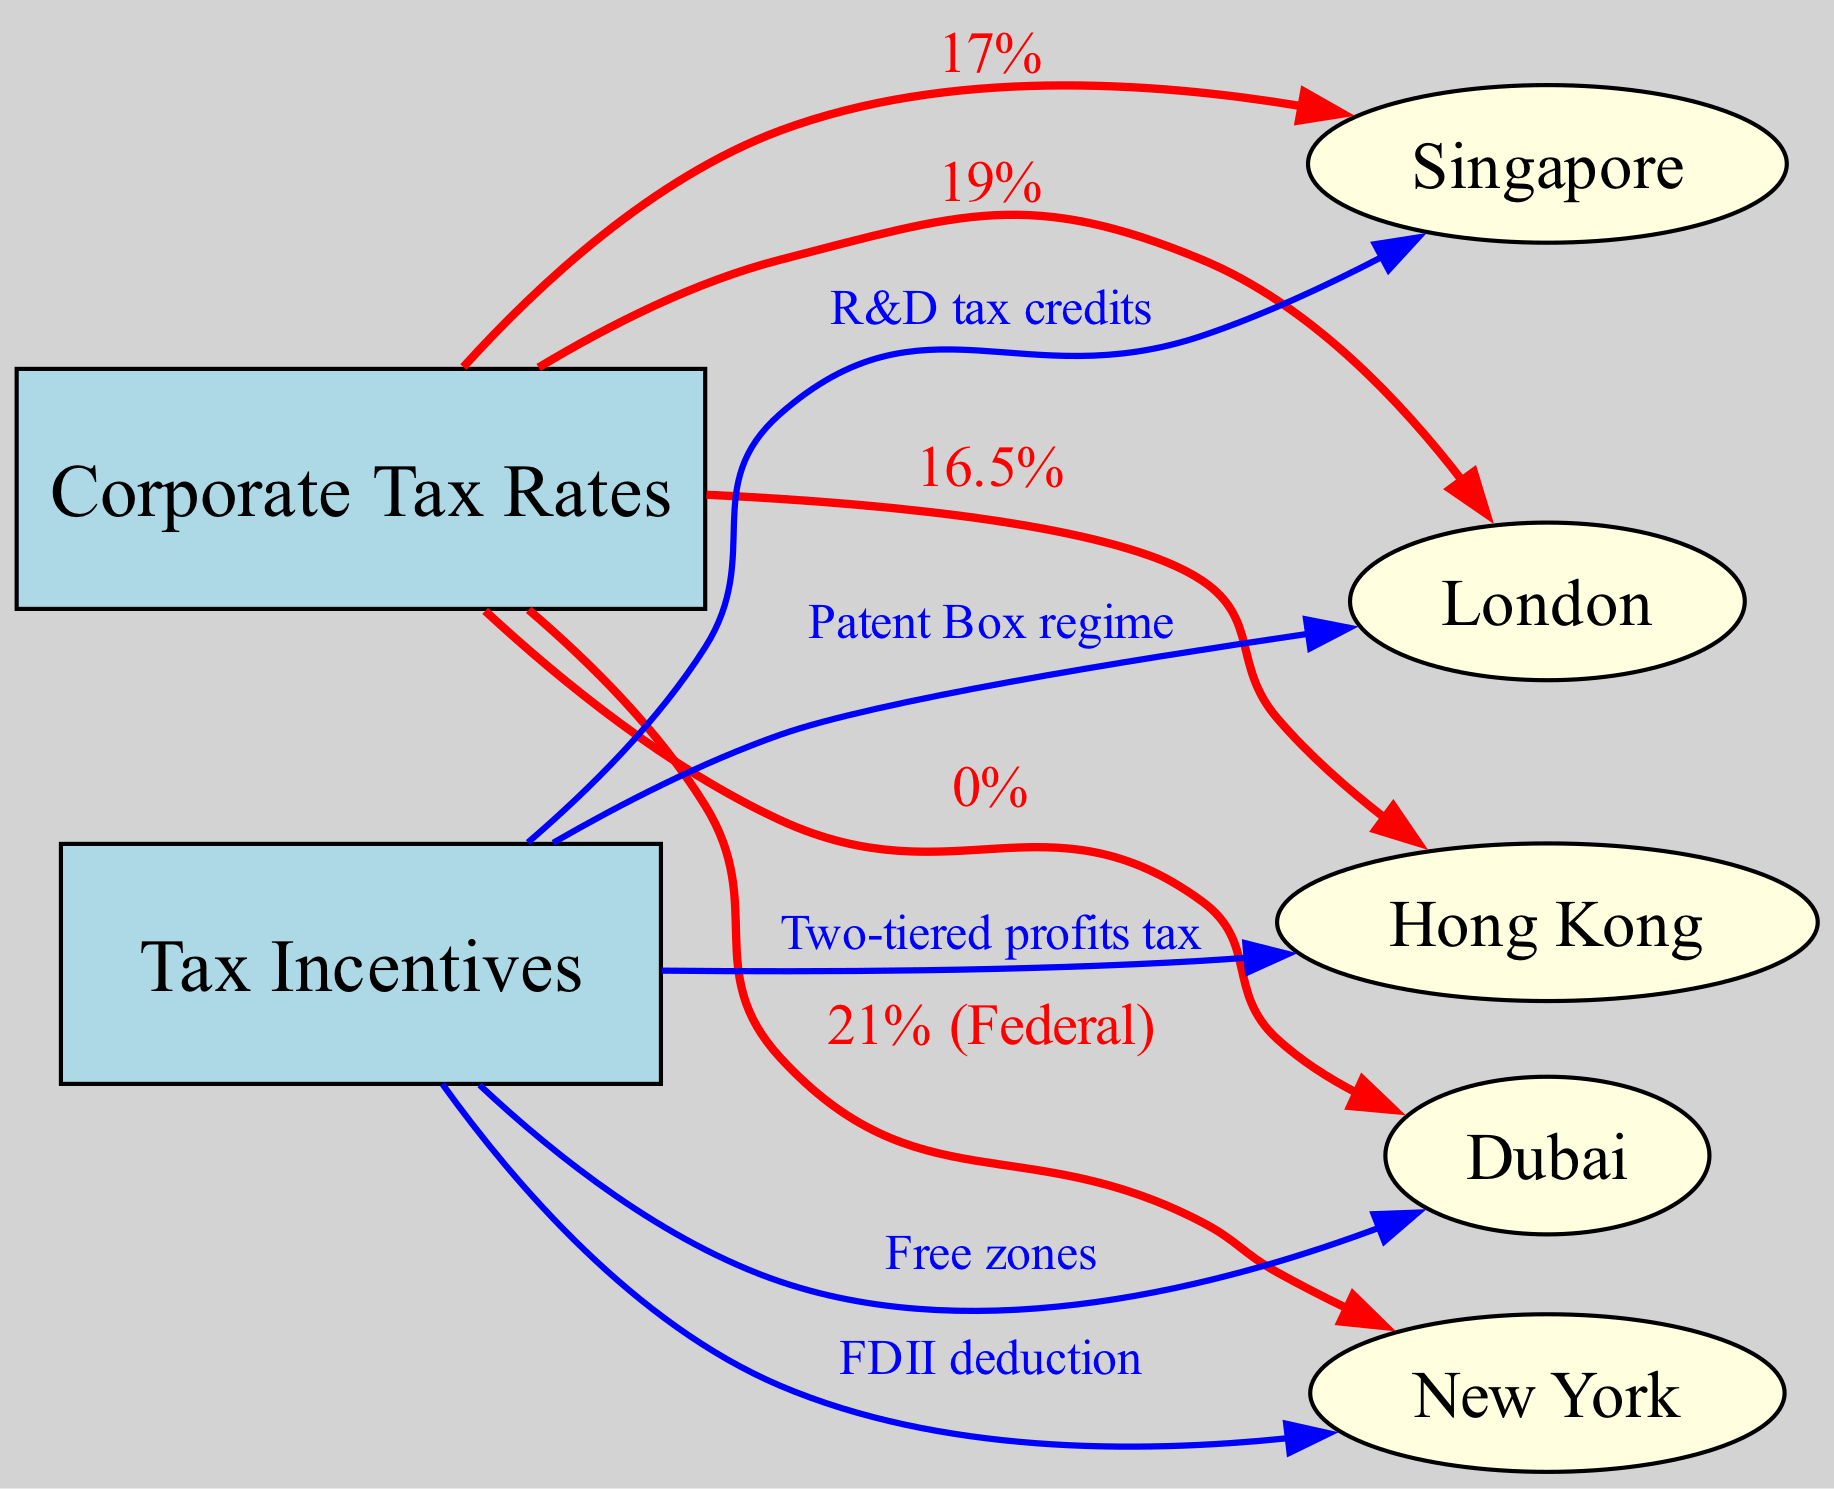What is the corporate tax rate in Singapore? In the diagram, the edge connecting "Corporate Tax Rates" to "Singapore" shows the label "17%", indicating that Singapore's corporate tax rate is 17%.
Answer: 17% What tax incentive is offered in Hong Kong? The edge connecting "Tax Incentives" to "Hong Kong" is labeled "Two-tiered profits tax", which means that this is the specific tax incentive provided in Hong Kong.
Answer: Two-tiered profits tax Which city has the lowest corporate tax rate? By analyzing the edges connected to "Corporate Tax Rates", the edge to "Dubai" shows a label of "0%", indicating that Dubai has the lowest corporate tax rate among the cities listed.
Answer: 0% What is the corporate tax rate in New York? In the diagram, the edge linking "Corporate Tax Rates" to "New York" indicates "21% (Federal)", which implies that New York has a federal corporate tax rate of 21%.
Answer: 21% (Federal) How many nodes are there in the diagram? The diagram contains a total of six city nodes plus two central nodes (Corporate Tax Rates and Tax Incentives), resulting in eight nodes altogether.
Answer: 8 Which city is associated with the FDII deduction? The edge directed from "Tax Incentives" to "New York" is labeled "FDII deduction", which shows that this tax incentive is specifically associated with New York.
Answer: New York What is the corporate tax rate in Hong Kong? The edge from "Corporate Tax Rates" to "Hong Kong" shows "16.5%", indicating that Hong Kong's corporate tax rate is 16.5%.
Answer: 16.5% What are the tax incentives provided for Singapore? The diagram features an edge from "Tax Incentives" to "Singapore" labeled "R&D tax credits", meaning that this is the specific incentive provided for Singapore.
Answer: R&D tax credits Which city utilizes a Patent Box regime as a tax incentive? Looking at the edge connecting "Tax Incentives" to "London", which is labeled "Patent Box regime", we can determine that London utilizes this specific incentive.
Answer: London 